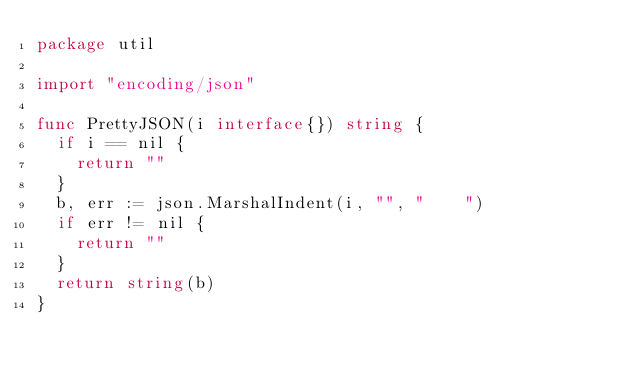Convert code to text. <code><loc_0><loc_0><loc_500><loc_500><_Go_>package util

import "encoding/json"

func PrettyJSON(i interface{}) string {
	if i == nil {
		return ""
	}
	b, err := json.MarshalIndent(i, "", "    ")
	if err != nil {
		return ""
	}
	return string(b)
}
</code> 